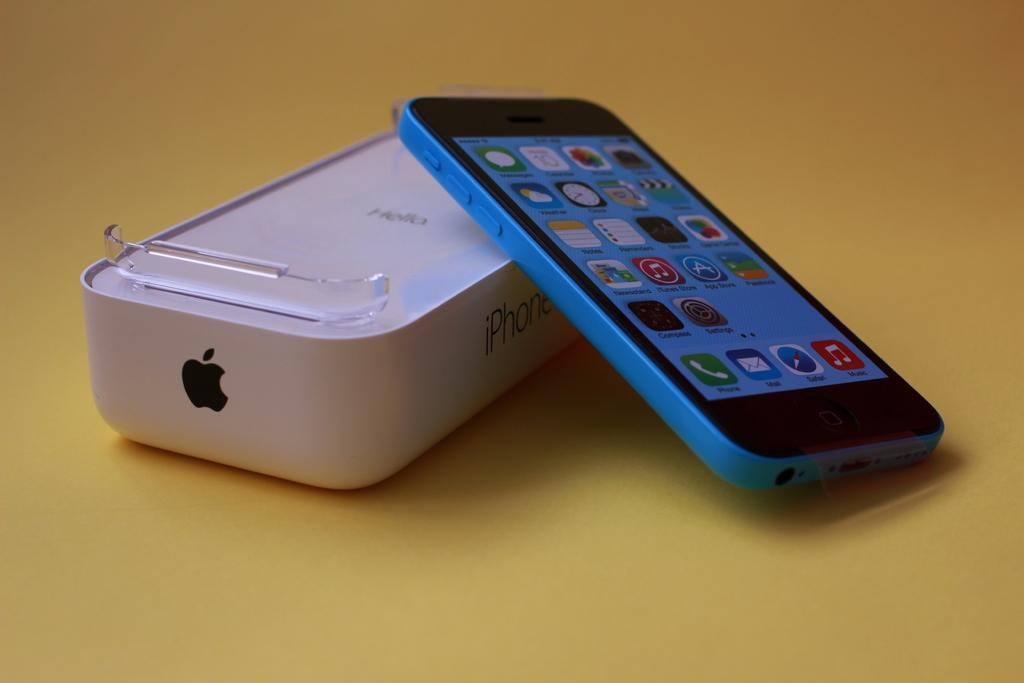What piece of furniture is present in the image? There is a table in the image. What electronic device is on the table? There is an iPhone on the table. Is there any packaging related to the iPhone visible in the image? Yes, there is an iPhone box on the table. What type of clam is sitting on the iPhone box in the image? There is no clam present in the image; it only features a table, an iPhone, and an iPhone box. 